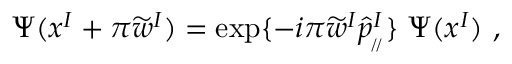Convert formula to latex. <formula><loc_0><loc_0><loc_500><loc_500>\Psi ( x ^ { I } + \pi \widetilde { w } ^ { I } ) = \exp \{ - i \pi \widetilde { w } ^ { I } \widehat { p } _ { _ { \, / \, / } } ^ { I } \} \ \Psi ( x ^ { I } ) \ ,</formula> 